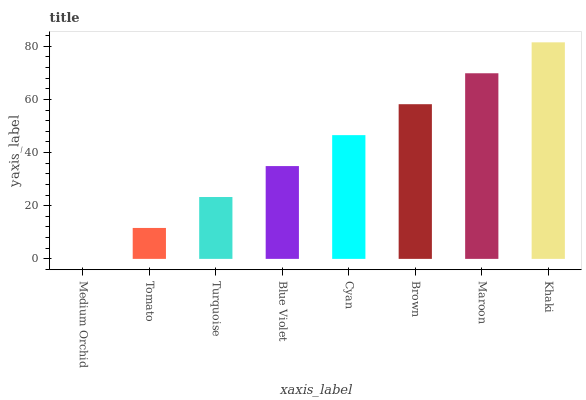Is Tomato the minimum?
Answer yes or no. No. Is Tomato the maximum?
Answer yes or no. No. Is Tomato greater than Medium Orchid?
Answer yes or no. Yes. Is Medium Orchid less than Tomato?
Answer yes or no. Yes. Is Medium Orchid greater than Tomato?
Answer yes or no. No. Is Tomato less than Medium Orchid?
Answer yes or no. No. Is Cyan the high median?
Answer yes or no. Yes. Is Blue Violet the low median?
Answer yes or no. Yes. Is Khaki the high median?
Answer yes or no. No. Is Khaki the low median?
Answer yes or no. No. 